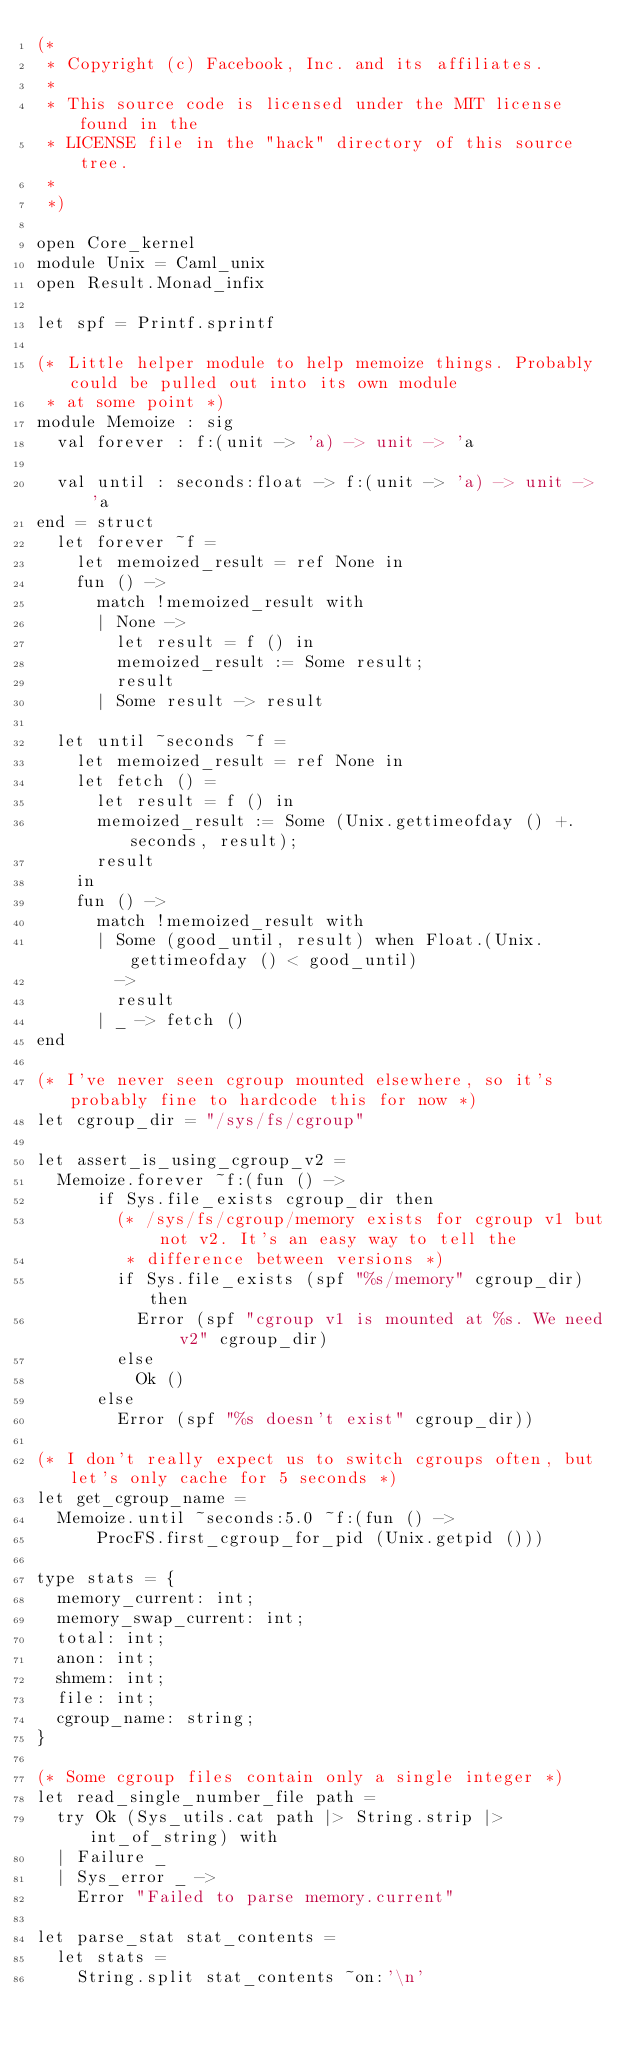<code> <loc_0><loc_0><loc_500><loc_500><_OCaml_>(*
 * Copyright (c) Facebook, Inc. and its affiliates.
 *
 * This source code is licensed under the MIT license found in the
 * LICENSE file in the "hack" directory of this source tree.
 *
 *)

open Core_kernel
module Unix = Caml_unix
open Result.Monad_infix

let spf = Printf.sprintf

(* Little helper module to help memoize things. Probably could be pulled out into its own module
 * at some point *)
module Memoize : sig
  val forever : f:(unit -> 'a) -> unit -> 'a

  val until : seconds:float -> f:(unit -> 'a) -> unit -> 'a
end = struct
  let forever ~f =
    let memoized_result = ref None in
    fun () ->
      match !memoized_result with
      | None ->
        let result = f () in
        memoized_result := Some result;
        result
      | Some result -> result

  let until ~seconds ~f =
    let memoized_result = ref None in
    let fetch () =
      let result = f () in
      memoized_result := Some (Unix.gettimeofday () +. seconds, result);
      result
    in
    fun () ->
      match !memoized_result with
      | Some (good_until, result) when Float.(Unix.gettimeofday () < good_until)
        ->
        result
      | _ -> fetch ()
end

(* I've never seen cgroup mounted elsewhere, so it's probably fine to hardcode this for now *)
let cgroup_dir = "/sys/fs/cgroup"

let assert_is_using_cgroup_v2 =
  Memoize.forever ~f:(fun () ->
      if Sys.file_exists cgroup_dir then
        (* /sys/fs/cgroup/memory exists for cgroup v1 but not v2. It's an easy way to tell the
         * difference between versions *)
        if Sys.file_exists (spf "%s/memory" cgroup_dir) then
          Error (spf "cgroup v1 is mounted at %s. We need v2" cgroup_dir)
        else
          Ok ()
      else
        Error (spf "%s doesn't exist" cgroup_dir))

(* I don't really expect us to switch cgroups often, but let's only cache for 5 seconds *)
let get_cgroup_name =
  Memoize.until ~seconds:5.0 ~f:(fun () ->
      ProcFS.first_cgroup_for_pid (Unix.getpid ()))

type stats = {
  memory_current: int;
  memory_swap_current: int;
  total: int;
  anon: int;
  shmem: int;
  file: int;
  cgroup_name: string;
}

(* Some cgroup files contain only a single integer *)
let read_single_number_file path =
  try Ok (Sys_utils.cat path |> String.strip |> int_of_string) with
  | Failure _
  | Sys_error _ ->
    Error "Failed to parse memory.current"

let parse_stat stat_contents =
  let stats =
    String.split stat_contents ~on:'\n'</code> 